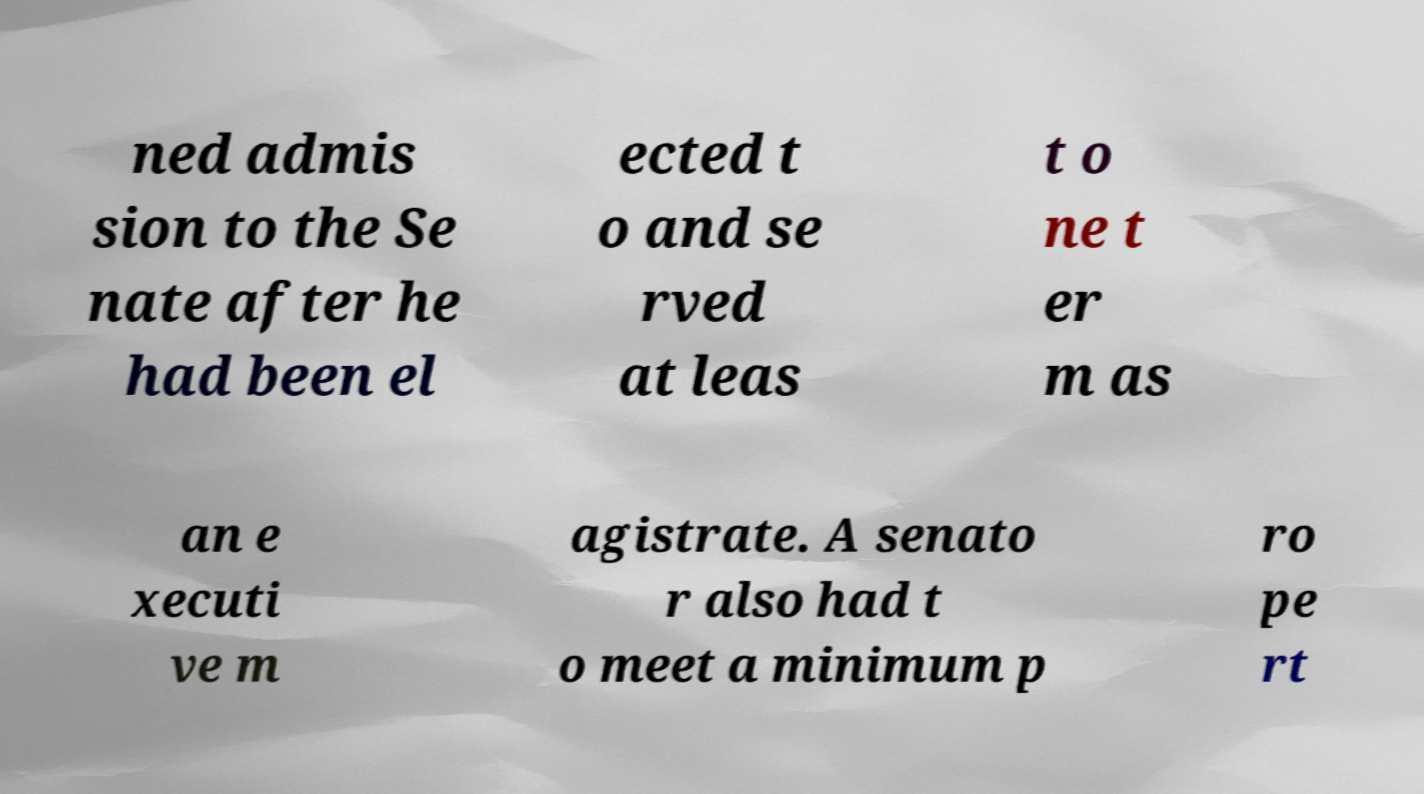Can you read and provide the text displayed in the image?This photo seems to have some interesting text. Can you extract and type it out for me? ned admis sion to the Se nate after he had been el ected t o and se rved at leas t o ne t er m as an e xecuti ve m agistrate. A senato r also had t o meet a minimum p ro pe rt 